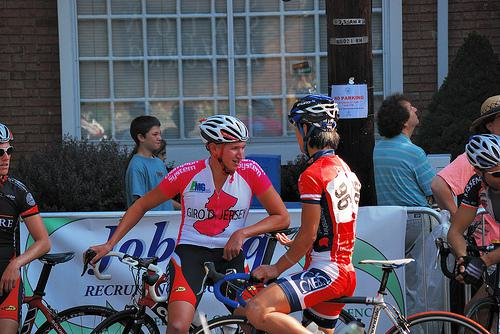How many unicorns are there in the image? There are no unicorns present in the image. The photograph captures a moment from a cycling event, featuring several cyclists and spectators, focusing on the sport rather than mythical creatures. 